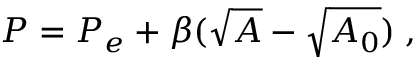Convert formula to latex. <formula><loc_0><loc_0><loc_500><loc_500>P = P _ { e } + \beta ( \sqrt { A } - \sqrt { A _ { 0 } } ) \, ,</formula> 